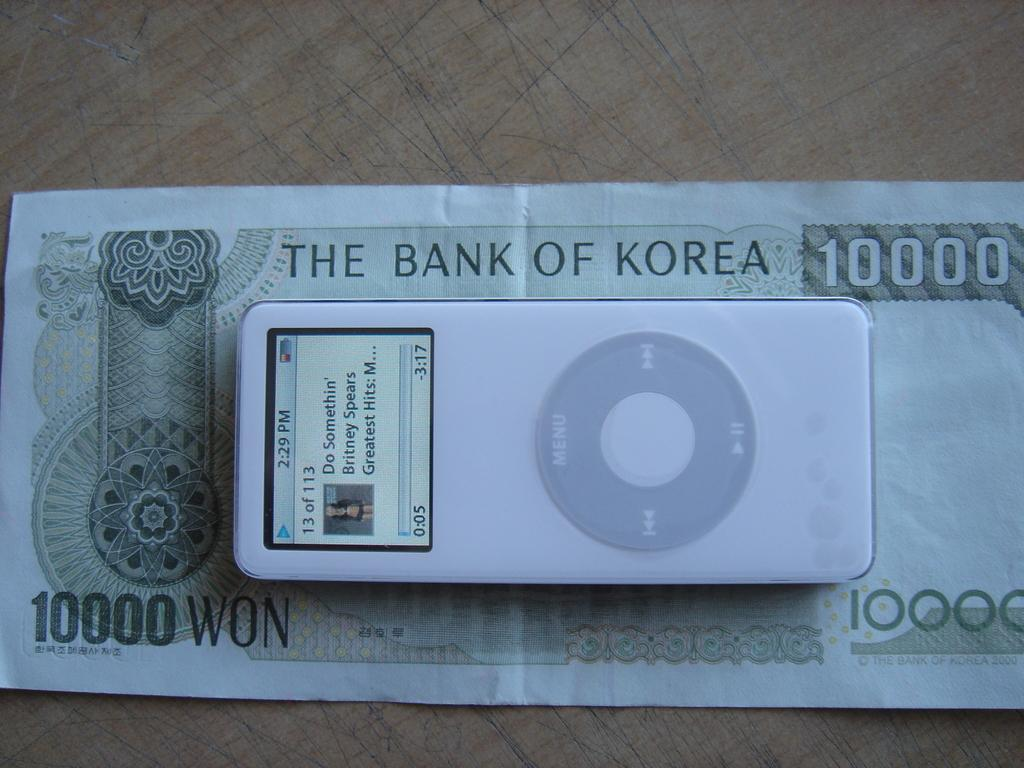What type of surface is visible in the image? There is a wooden platform in the image. What is placed on the wooden platform? There is a currency note and a gadget on the wooden platform. What type of soup is being served on the wooden platform? There is no soup present on the wooden platform in the image. 